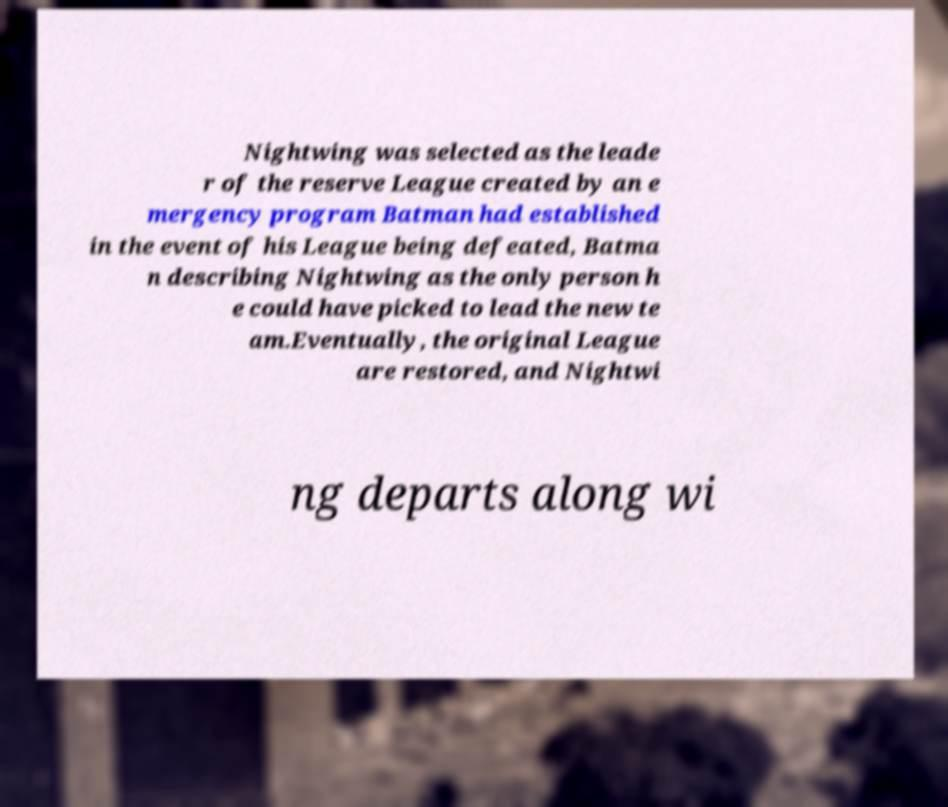Can you read and provide the text displayed in the image?This photo seems to have some interesting text. Can you extract and type it out for me? Nightwing was selected as the leade r of the reserve League created by an e mergency program Batman had established in the event of his League being defeated, Batma n describing Nightwing as the only person h e could have picked to lead the new te am.Eventually, the original League are restored, and Nightwi ng departs along wi 